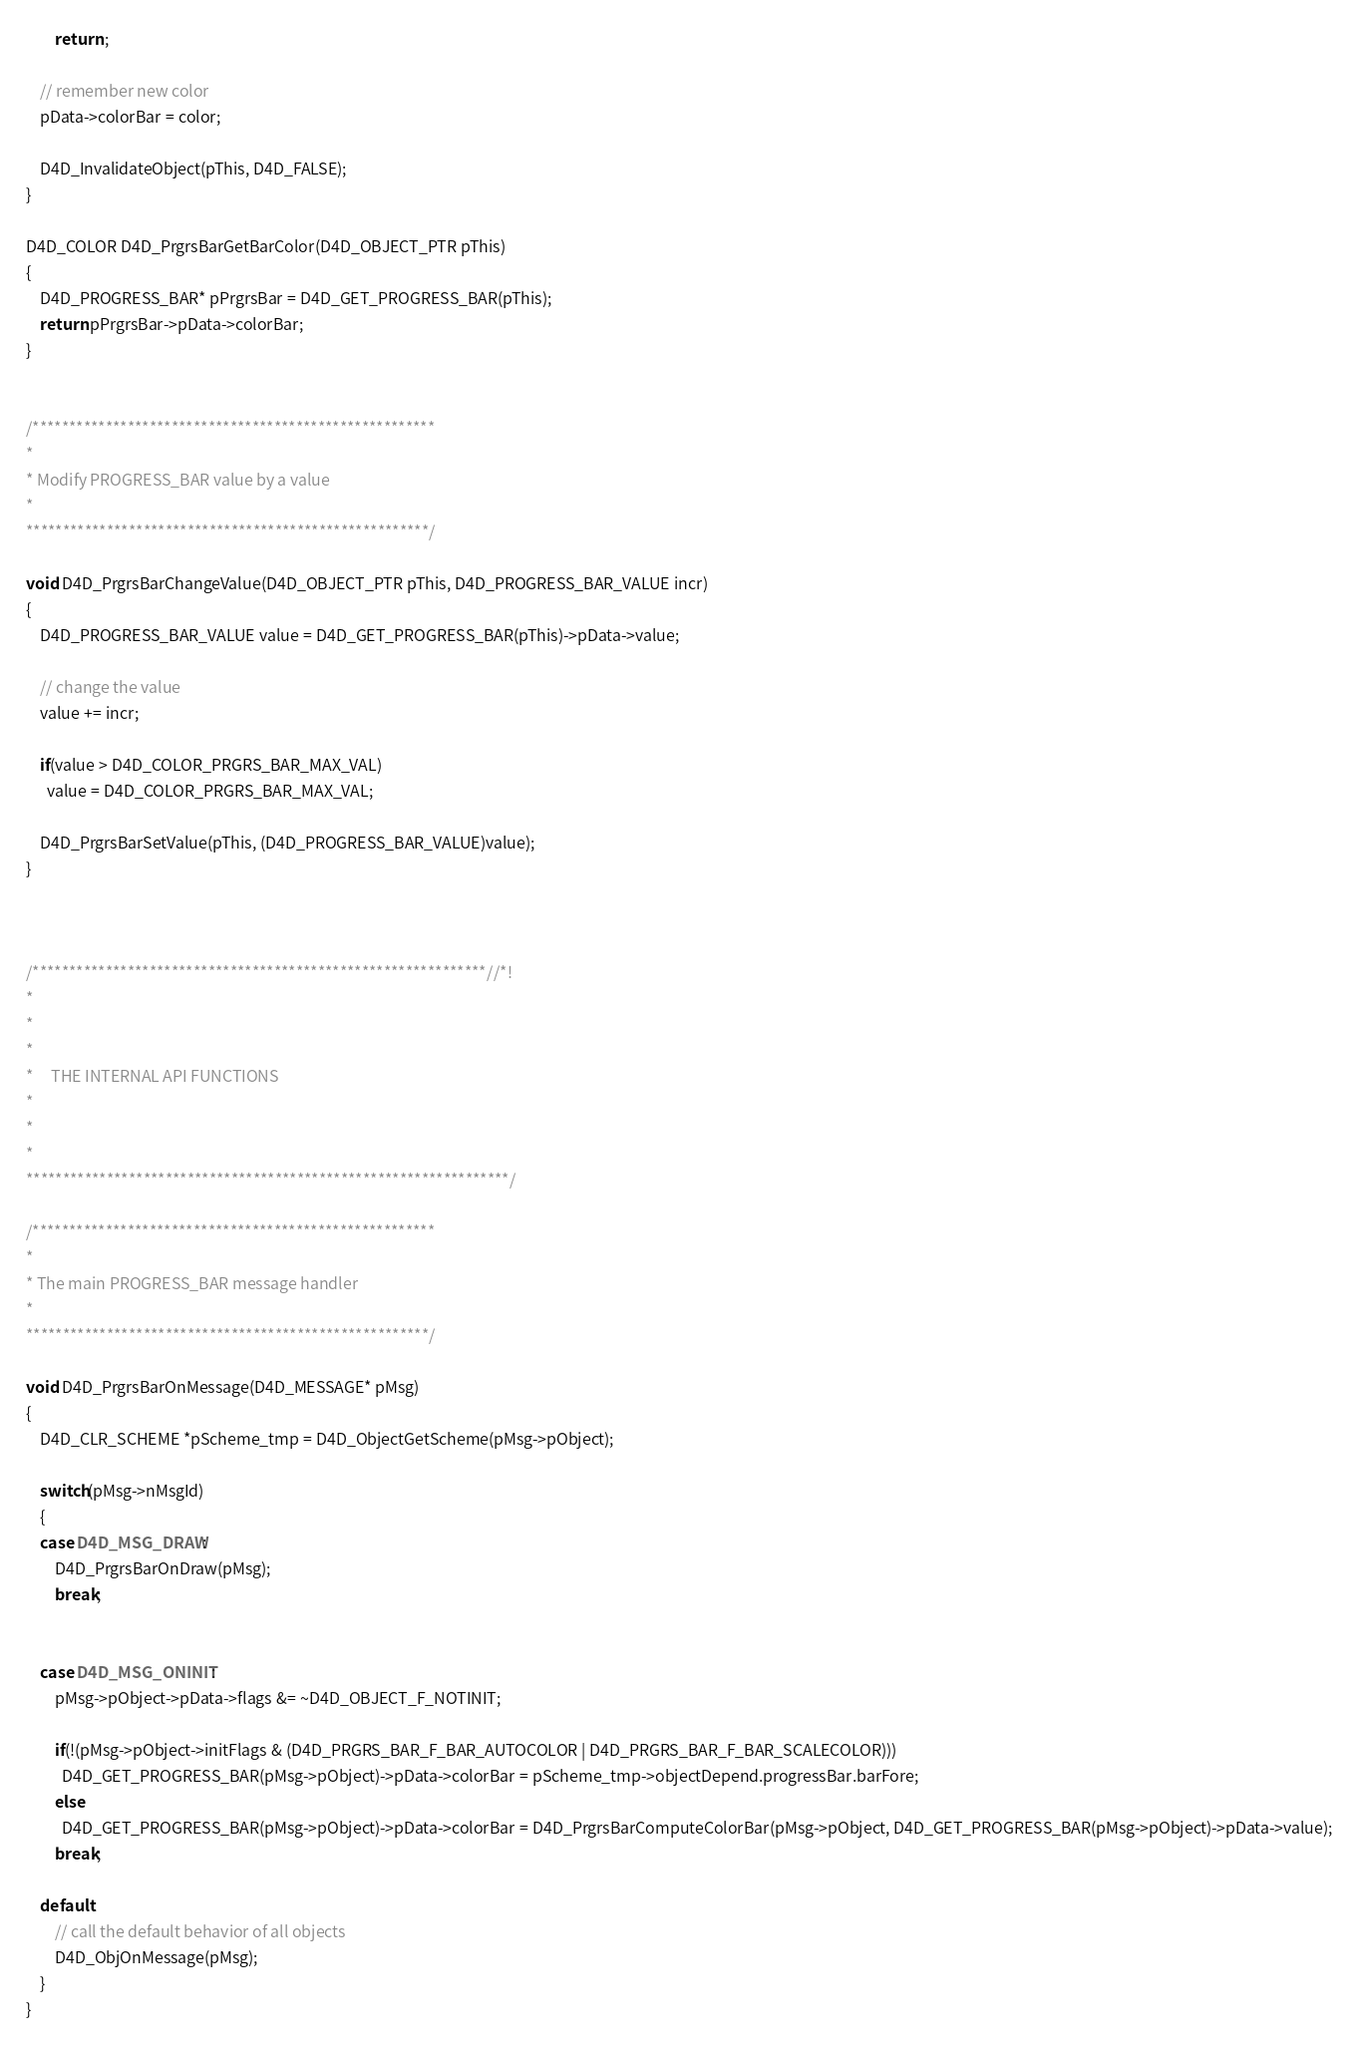<code> <loc_0><loc_0><loc_500><loc_500><_C_>        return ;

    // remember new color
    pData->colorBar = color;

    D4D_InvalidateObject(pThis, D4D_FALSE);
}

D4D_COLOR D4D_PrgrsBarGetBarColor(D4D_OBJECT_PTR pThis)
{
    D4D_PROGRESS_BAR* pPrgrsBar = D4D_GET_PROGRESS_BAR(pThis);
    return pPrgrsBar->pData->colorBar;
}


/*******************************************************
*
* Modify PROGRESS_BAR value by a value
*
*******************************************************/

void D4D_PrgrsBarChangeValue(D4D_OBJECT_PTR pThis, D4D_PROGRESS_BAR_VALUE incr)
{
    D4D_PROGRESS_BAR_VALUE value = D4D_GET_PROGRESS_BAR(pThis)->pData->value;

    // change the value
    value += incr;

    if(value > D4D_COLOR_PRGRS_BAR_MAX_VAL)
      value = D4D_COLOR_PRGRS_BAR_MAX_VAL;

    D4D_PrgrsBarSetValue(pThis, (D4D_PROGRESS_BAR_VALUE)value);
}



/**************************************************************//*!
*
*
*
*     THE INTERNAL API FUNCTIONS
*
*
*
******************************************************************/

/*******************************************************
*
* The main PROGRESS_BAR message handler
*
*******************************************************/

void D4D_PrgrsBarOnMessage(D4D_MESSAGE* pMsg)
{
    D4D_CLR_SCHEME *pScheme_tmp = D4D_ObjectGetScheme(pMsg->pObject);

    switch(pMsg->nMsgId)
    {
    case D4D_MSG_DRAW:
        D4D_PrgrsBarOnDraw(pMsg);
        break;


    case D4D_MSG_ONINIT:
        pMsg->pObject->pData->flags &= ~D4D_OBJECT_F_NOTINIT;

        if(!(pMsg->pObject->initFlags & (D4D_PRGRS_BAR_F_BAR_AUTOCOLOR | D4D_PRGRS_BAR_F_BAR_SCALECOLOR)))
          D4D_GET_PROGRESS_BAR(pMsg->pObject)->pData->colorBar = pScheme_tmp->objectDepend.progressBar.barFore;
        else
          D4D_GET_PROGRESS_BAR(pMsg->pObject)->pData->colorBar = D4D_PrgrsBarComputeColorBar(pMsg->pObject, D4D_GET_PROGRESS_BAR(pMsg->pObject)->pData->value);
        break;

    default:
        // call the default behavior of all objects
        D4D_ObjOnMessage(pMsg);
    }
}

</code> 